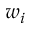Convert formula to latex. <formula><loc_0><loc_0><loc_500><loc_500>w _ { i }</formula> 